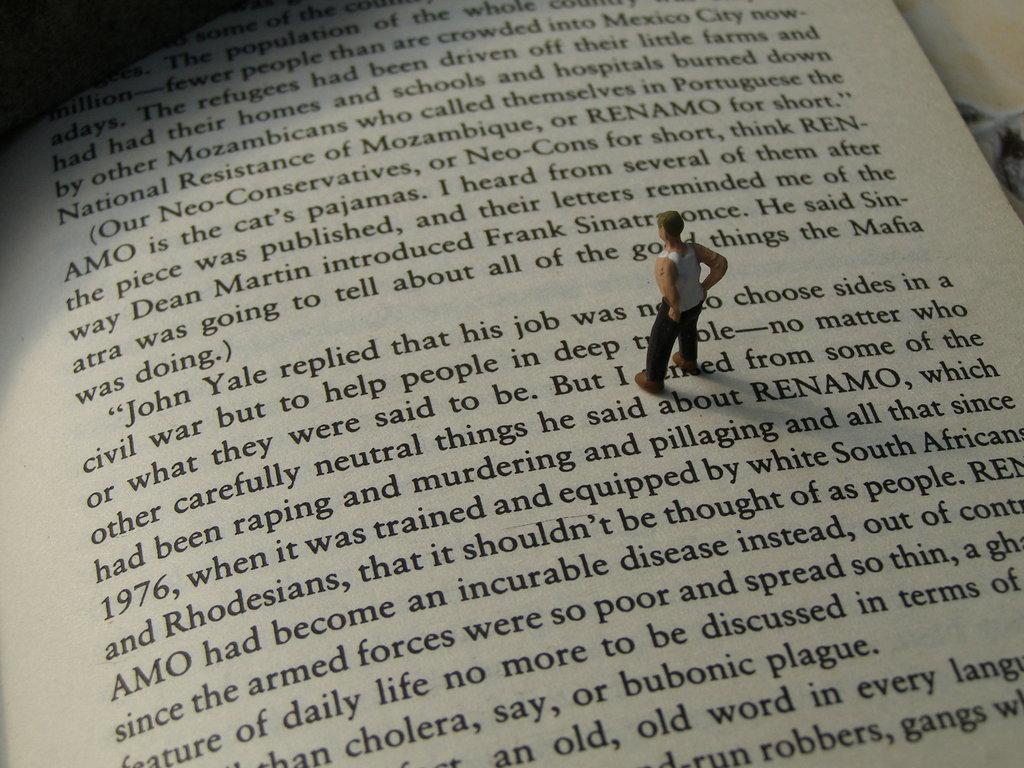<image>
Share a concise interpretation of the image provided. A photo of a book about South Africa and Rhodesia with a small figurine of a man standing on top of it. 